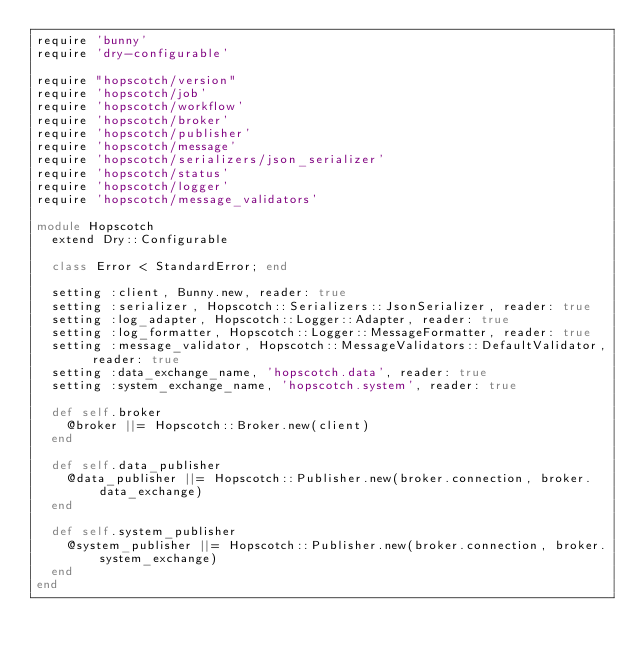Convert code to text. <code><loc_0><loc_0><loc_500><loc_500><_Ruby_>require 'bunny'
require 'dry-configurable'

require "hopscotch/version"
require 'hopscotch/job'
require 'hopscotch/workflow'
require 'hopscotch/broker'
require 'hopscotch/publisher'
require 'hopscotch/message'
require 'hopscotch/serializers/json_serializer'
require 'hopscotch/status'
require 'hopscotch/logger'
require 'hopscotch/message_validators'

module Hopscotch
  extend Dry::Configurable

  class Error < StandardError; end

  setting :client, Bunny.new, reader: true
  setting :serializer, Hopscotch::Serializers::JsonSerializer, reader: true
  setting :log_adapter, Hopscotch::Logger::Adapter, reader: true
  setting :log_formatter, Hopscotch::Logger::MessageFormatter, reader: true
  setting :message_validator, Hopscotch::MessageValidators::DefaultValidator, reader: true
  setting :data_exchange_name, 'hopscotch.data', reader: true
  setting :system_exchange_name, 'hopscotch.system', reader: true

  def self.broker
    @broker ||= Hopscotch::Broker.new(client)
  end

  def self.data_publisher
    @data_publisher ||= Hopscotch::Publisher.new(broker.connection, broker.data_exchange)
  end

  def self.system_publisher
    @system_publisher ||= Hopscotch::Publisher.new(broker.connection, broker.system_exchange)
  end
end
</code> 